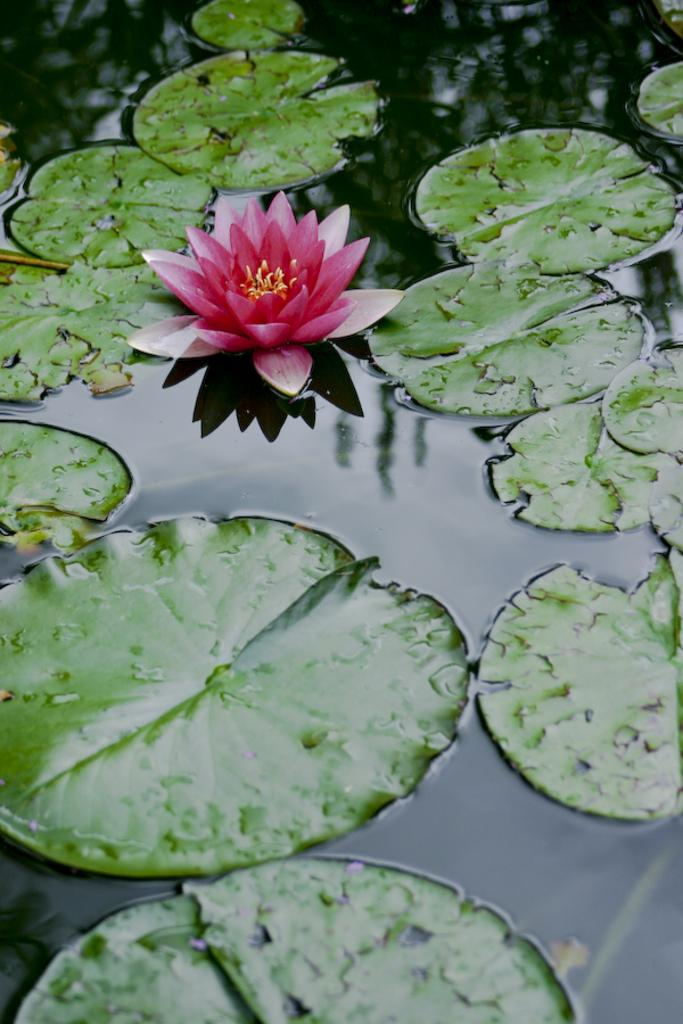What type of flower is in the image? There is a lotus flower in the image. What else can be seen in the image besides the lotus flower? There are leaves in the image. Where are the lotus flower and leaves located? The lotus flower and leaves are on water. What is the beginner's level of understanding about the purpose of the lotus flower in the image? There is no indication of a beginner's level of understanding or any purpose associated with the lotus flower in the image. 